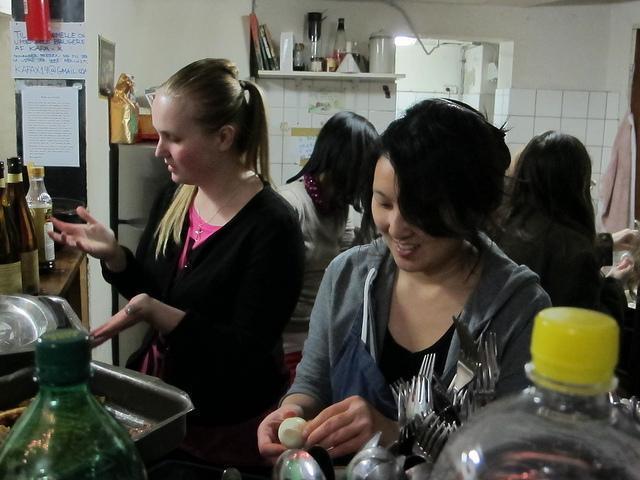How many colors of the rainbow are represented by the bottle tops at the front of the scene?
Give a very brief answer. 2. How many bottles are there?
Give a very brief answer. 3. How many people are there?
Give a very brief answer. 4. 